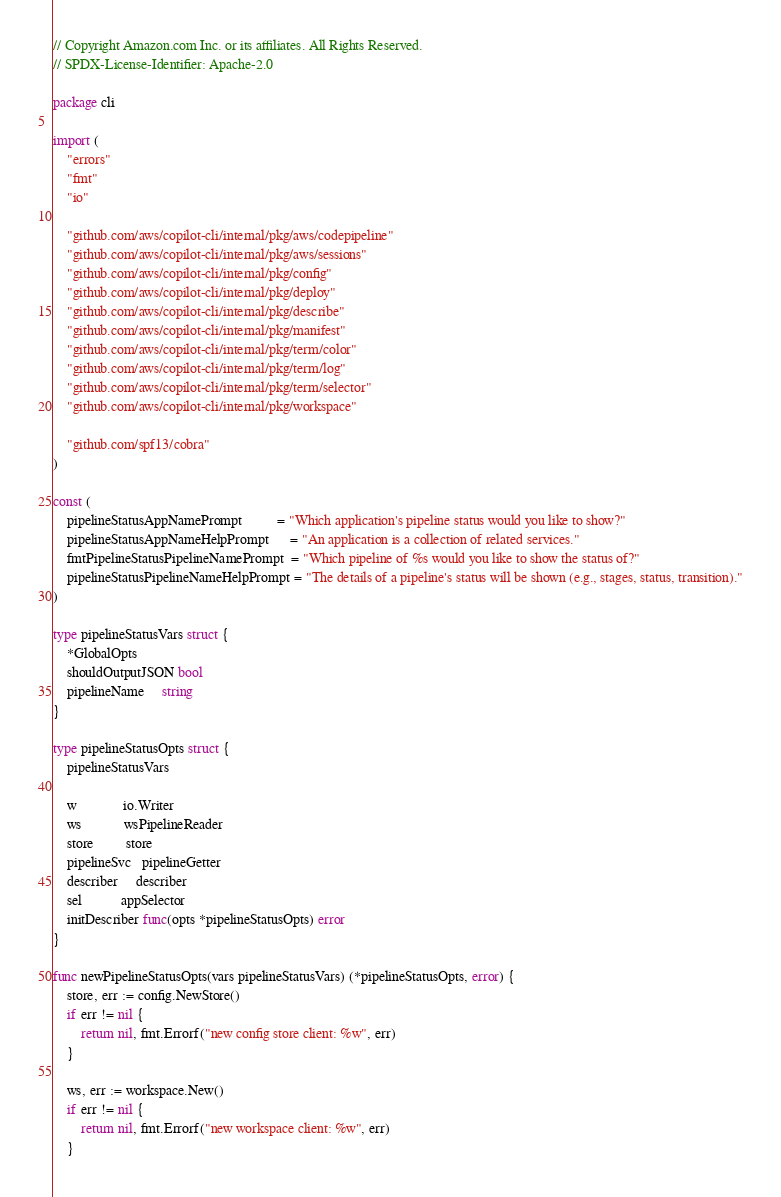<code> <loc_0><loc_0><loc_500><loc_500><_Go_>// Copyright Amazon.com Inc. or its affiliates. All Rights Reserved.
// SPDX-License-Identifier: Apache-2.0

package cli

import (
	"errors"
	"fmt"
	"io"

	"github.com/aws/copilot-cli/internal/pkg/aws/codepipeline"
	"github.com/aws/copilot-cli/internal/pkg/aws/sessions"
	"github.com/aws/copilot-cli/internal/pkg/config"
	"github.com/aws/copilot-cli/internal/pkg/deploy"
	"github.com/aws/copilot-cli/internal/pkg/describe"
	"github.com/aws/copilot-cli/internal/pkg/manifest"
	"github.com/aws/copilot-cli/internal/pkg/term/color"
	"github.com/aws/copilot-cli/internal/pkg/term/log"
	"github.com/aws/copilot-cli/internal/pkg/term/selector"
	"github.com/aws/copilot-cli/internal/pkg/workspace"

	"github.com/spf13/cobra"
)

const (
	pipelineStatusAppNamePrompt          = "Which application's pipeline status would you like to show?"
	pipelineStatusAppNameHelpPrompt      = "An application is a collection of related services."
	fmtPipelineStatusPipelineNamePrompt  = "Which pipeline of %s would you like to show the status of?"
	pipelineStatusPipelineNameHelpPrompt = "The details of a pipeline's status will be shown (e.g., stages, status, transition)."
)

type pipelineStatusVars struct {
	*GlobalOpts
	shouldOutputJSON bool
	pipelineName     string
}

type pipelineStatusOpts struct {
	pipelineStatusVars

	w             io.Writer
	ws            wsPipelineReader
	store         store
	pipelineSvc   pipelineGetter
	describer     describer
	sel           appSelector
	initDescriber func(opts *pipelineStatusOpts) error
}

func newPipelineStatusOpts(vars pipelineStatusVars) (*pipelineStatusOpts, error) {
	store, err := config.NewStore()
	if err != nil {
		return nil, fmt.Errorf("new config store client: %w", err)
	}

	ws, err := workspace.New()
	if err != nil {
		return nil, fmt.Errorf("new workspace client: %w", err)
	}
</code> 